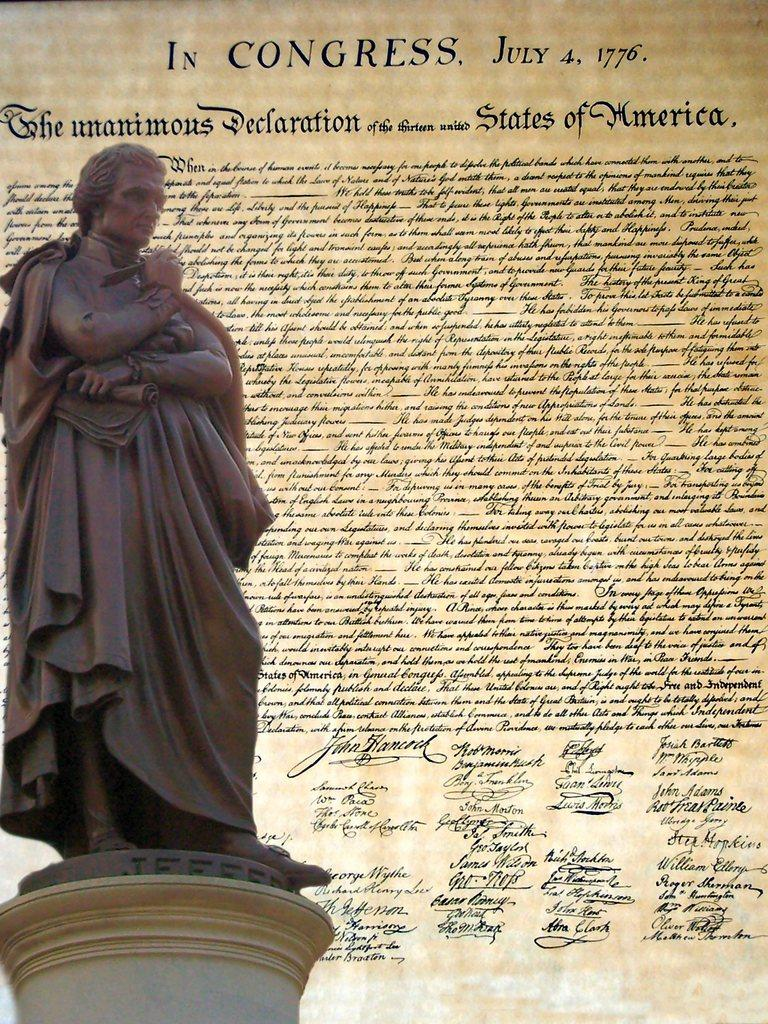What is the main subject of the image? There is a statue in the image. Can you describe the background of the image? There is a poster with text in the background of the image. What type of yoke is the statue holding in the image? There is no yoke present in the image; the statue is not holding any object. Is there a guitar visible in the image? No, there is no guitar present in the image. 